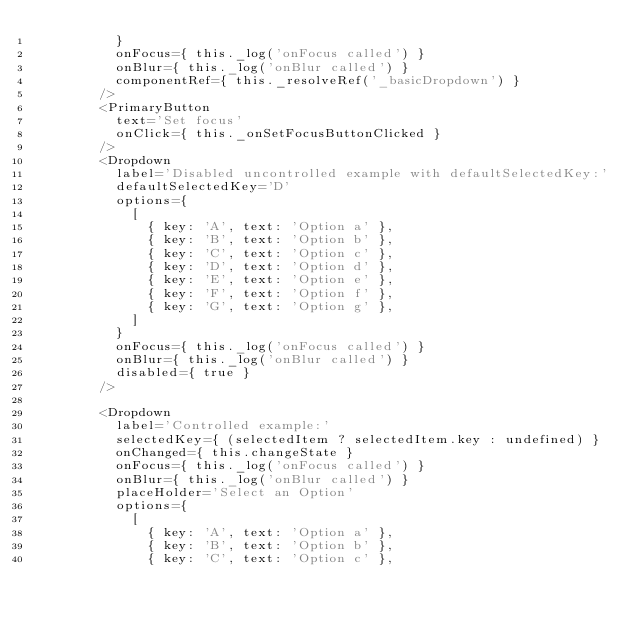<code> <loc_0><loc_0><loc_500><loc_500><_TypeScript_>          }
          onFocus={ this._log('onFocus called') }
          onBlur={ this._log('onBlur called') }
          componentRef={ this._resolveRef('_basicDropdown') }
        />
        <PrimaryButton
          text='Set focus'
          onClick={ this._onSetFocusButtonClicked }
        />
        <Dropdown
          label='Disabled uncontrolled example with defaultSelectedKey:'
          defaultSelectedKey='D'
          options={
            [
              { key: 'A', text: 'Option a' },
              { key: 'B', text: 'Option b' },
              { key: 'C', text: 'Option c' },
              { key: 'D', text: 'Option d' },
              { key: 'E', text: 'Option e' },
              { key: 'F', text: 'Option f' },
              { key: 'G', text: 'Option g' },
            ]
          }
          onFocus={ this._log('onFocus called') }
          onBlur={ this._log('onBlur called') }
          disabled={ true }
        />

        <Dropdown
          label='Controlled example:'
          selectedKey={ (selectedItem ? selectedItem.key : undefined) }
          onChanged={ this.changeState }
          onFocus={ this._log('onFocus called') }
          onBlur={ this._log('onBlur called') }
          placeHolder='Select an Option'
          options={
            [
              { key: 'A', text: 'Option a' },
              { key: 'B', text: 'Option b' },
              { key: 'C', text: 'Option c' },</code> 